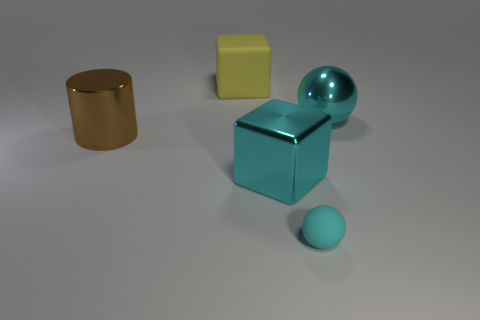Are there any other things that have the same size as the rubber ball?
Your answer should be very brief. No. There is a tiny object in front of the big ball; is it the same shape as the brown metallic thing?
Offer a terse response. No. The large cube that is the same material as the tiny thing is what color?
Ensure brevity in your answer.  Yellow. How many big things have the same material as the large ball?
Offer a very short reply. 2. There is a matte object that is behind the cyan sphere behind the large cube that is in front of the big yellow cube; what is its color?
Offer a terse response. Yellow. Do the cyan cube and the shiny cylinder have the same size?
Give a very brief answer. Yes. Are there any other things that are the same shape as the tiny object?
Offer a very short reply. Yes. What number of things are metal things that are in front of the metal cylinder or large red metallic spheres?
Your answer should be compact. 1. Is the tiny rubber thing the same shape as the brown metallic object?
Provide a succinct answer. No. How many other objects are there of the same size as the cyan matte ball?
Your answer should be very brief. 0. 